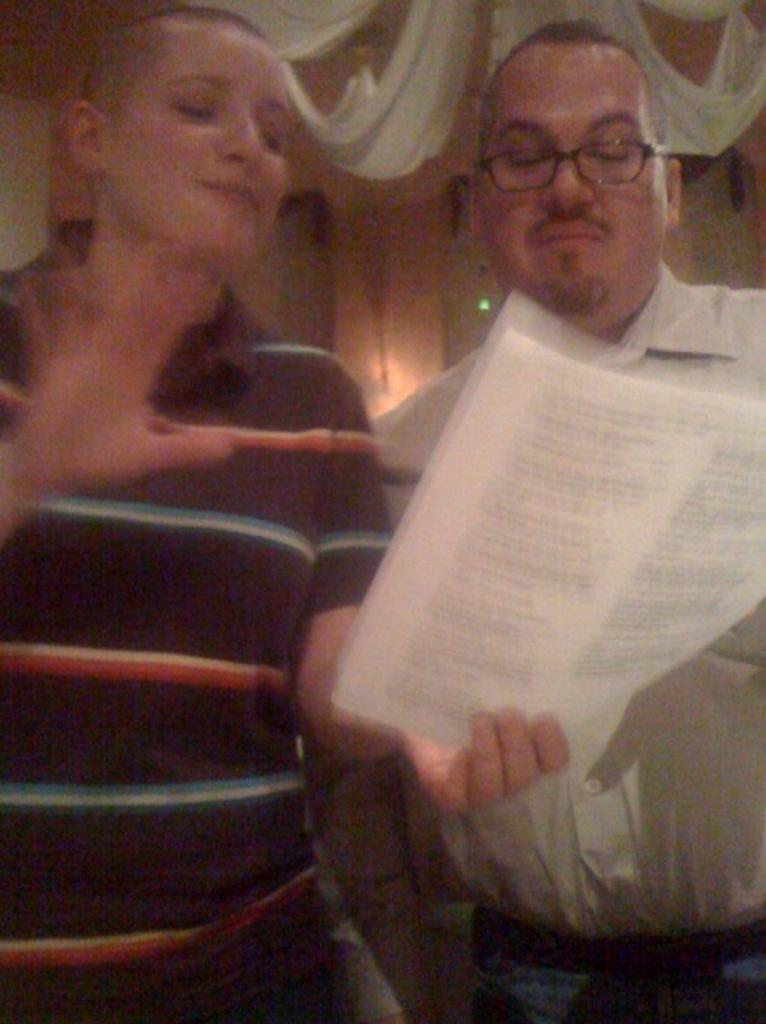How many people are present in the image? There are two people in the image. What can be seen in addition to the people in the image? There is a white cloth visible in the image. What type of string is being used by the representative in the image? There is no representative or string present in the image. What is the hammer being used for in the image? There is no hammer present in the image. 